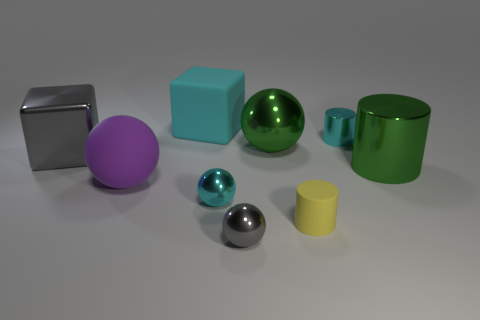Add 1 small yellow cylinders. How many objects exist? 10 Subtract all spheres. How many objects are left? 5 Subtract 0 blue balls. How many objects are left? 9 Subtract all tiny blue shiny things. Subtract all balls. How many objects are left? 5 Add 1 purple rubber balls. How many purple rubber balls are left? 2 Add 9 purple rubber balls. How many purple rubber balls exist? 10 